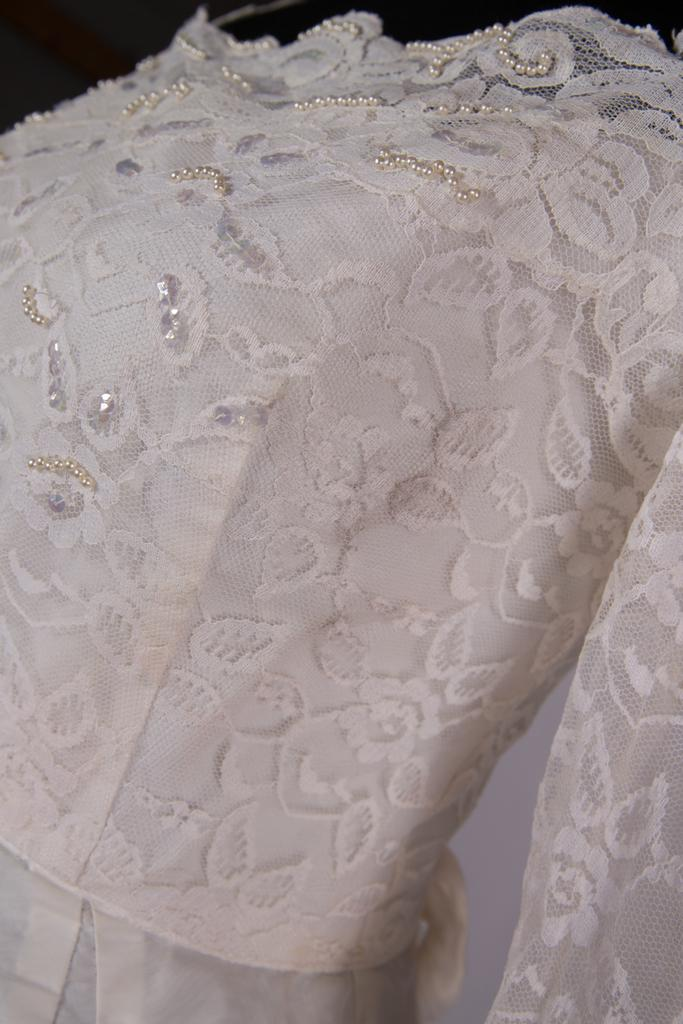What color is the dress in the image? The dress in the image is white-colored. What type of nerve can be seen in the image? There is no nerve present in the image; it features a white-colored dress. Is the dress located in downtown in the image? The provided facts do not mention the location of the dress or any reference to downtown, so it cannot be determined from the image. 